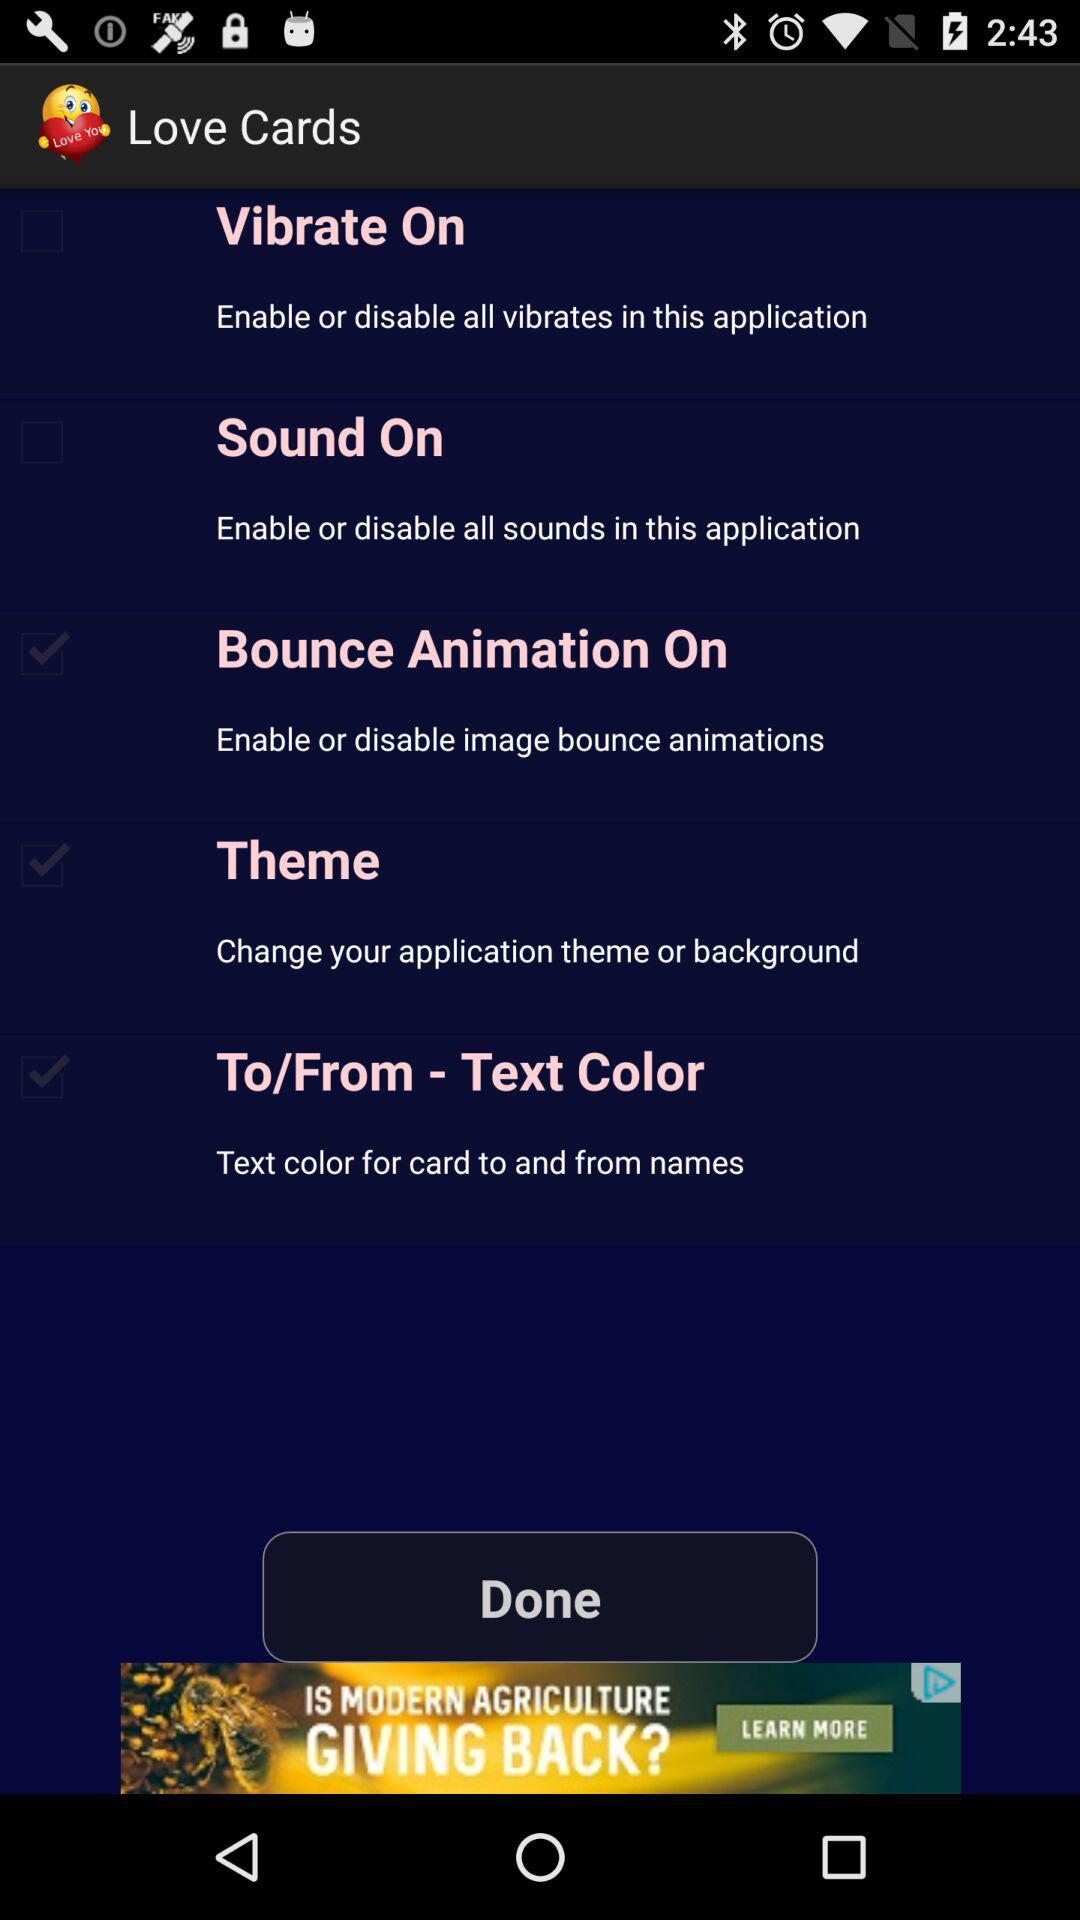What is the application name? The application name is "Love Cards". 